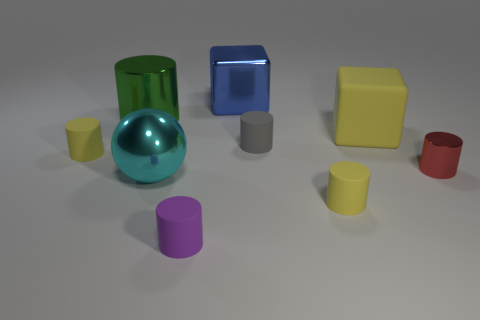What number of large objects are on the right side of the large metallic ball and behind the big matte block?
Offer a terse response. 1. What is the material of the object that is both in front of the blue cube and behind the large matte object?
Offer a terse response. Metal. Are there fewer large cylinders that are right of the tiny red metal cylinder than green metallic cylinders to the left of the big yellow cube?
Give a very brief answer. Yes. What is the size of the cyan sphere that is the same material as the blue block?
Keep it short and to the point. Large. Is there anything else that is the same color as the large matte cube?
Offer a very short reply. Yes. Does the sphere have the same material as the yellow thing left of the cyan metallic thing?
Make the answer very short. No. What material is the small red object that is the same shape as the green thing?
Keep it short and to the point. Metal. Do the cube to the left of the large yellow object and the cylinder that is on the left side of the green shiny thing have the same material?
Your answer should be very brief. No. The rubber cylinder right of the tiny cylinder behind the matte object left of the green cylinder is what color?
Ensure brevity in your answer.  Yellow. What number of other objects are the same shape as the large green thing?
Ensure brevity in your answer.  5. 